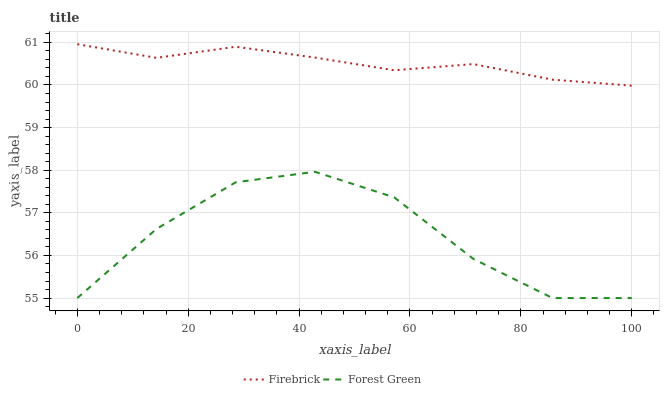Does Forest Green have the minimum area under the curve?
Answer yes or no. Yes. Does Firebrick have the maximum area under the curve?
Answer yes or no. Yes. Does Forest Green have the maximum area under the curve?
Answer yes or no. No. Is Firebrick the smoothest?
Answer yes or no. Yes. Is Forest Green the roughest?
Answer yes or no. Yes. Is Forest Green the smoothest?
Answer yes or no. No. Does Forest Green have the lowest value?
Answer yes or no. Yes. Does Firebrick have the highest value?
Answer yes or no. Yes. Does Forest Green have the highest value?
Answer yes or no. No. Is Forest Green less than Firebrick?
Answer yes or no. Yes. Is Firebrick greater than Forest Green?
Answer yes or no. Yes. Does Forest Green intersect Firebrick?
Answer yes or no. No. 